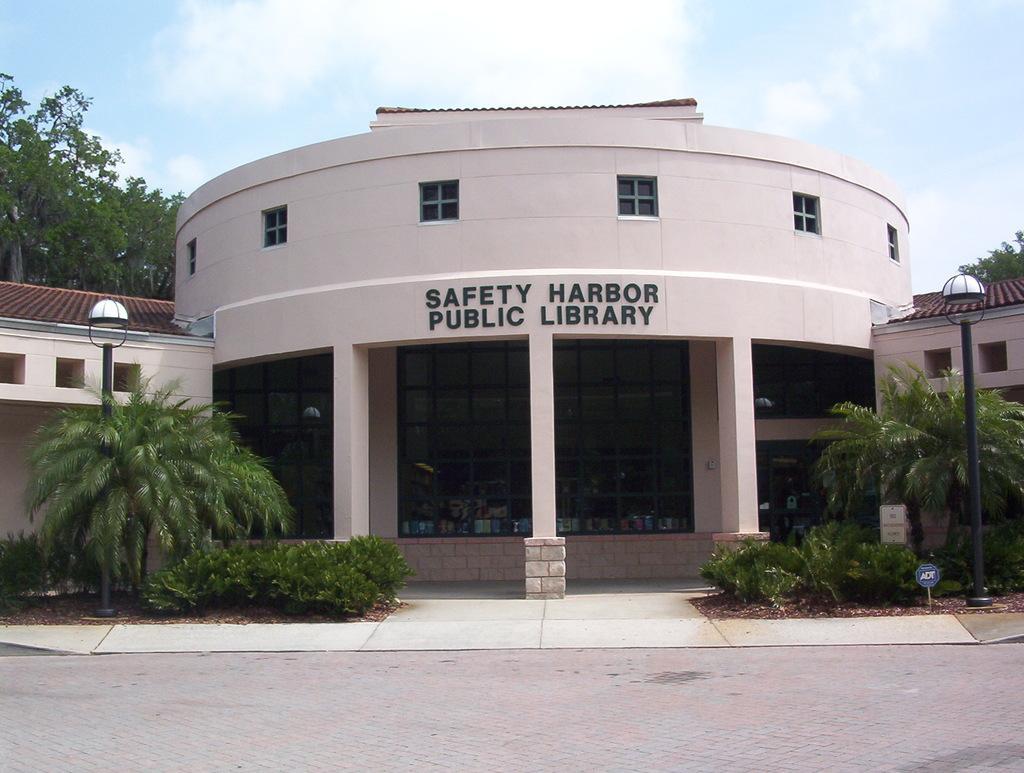In one or two sentences, can you explain what this image depicts? In this image there is a pavement, in the background there are plants, trees, light poles, buildings and the sky. 